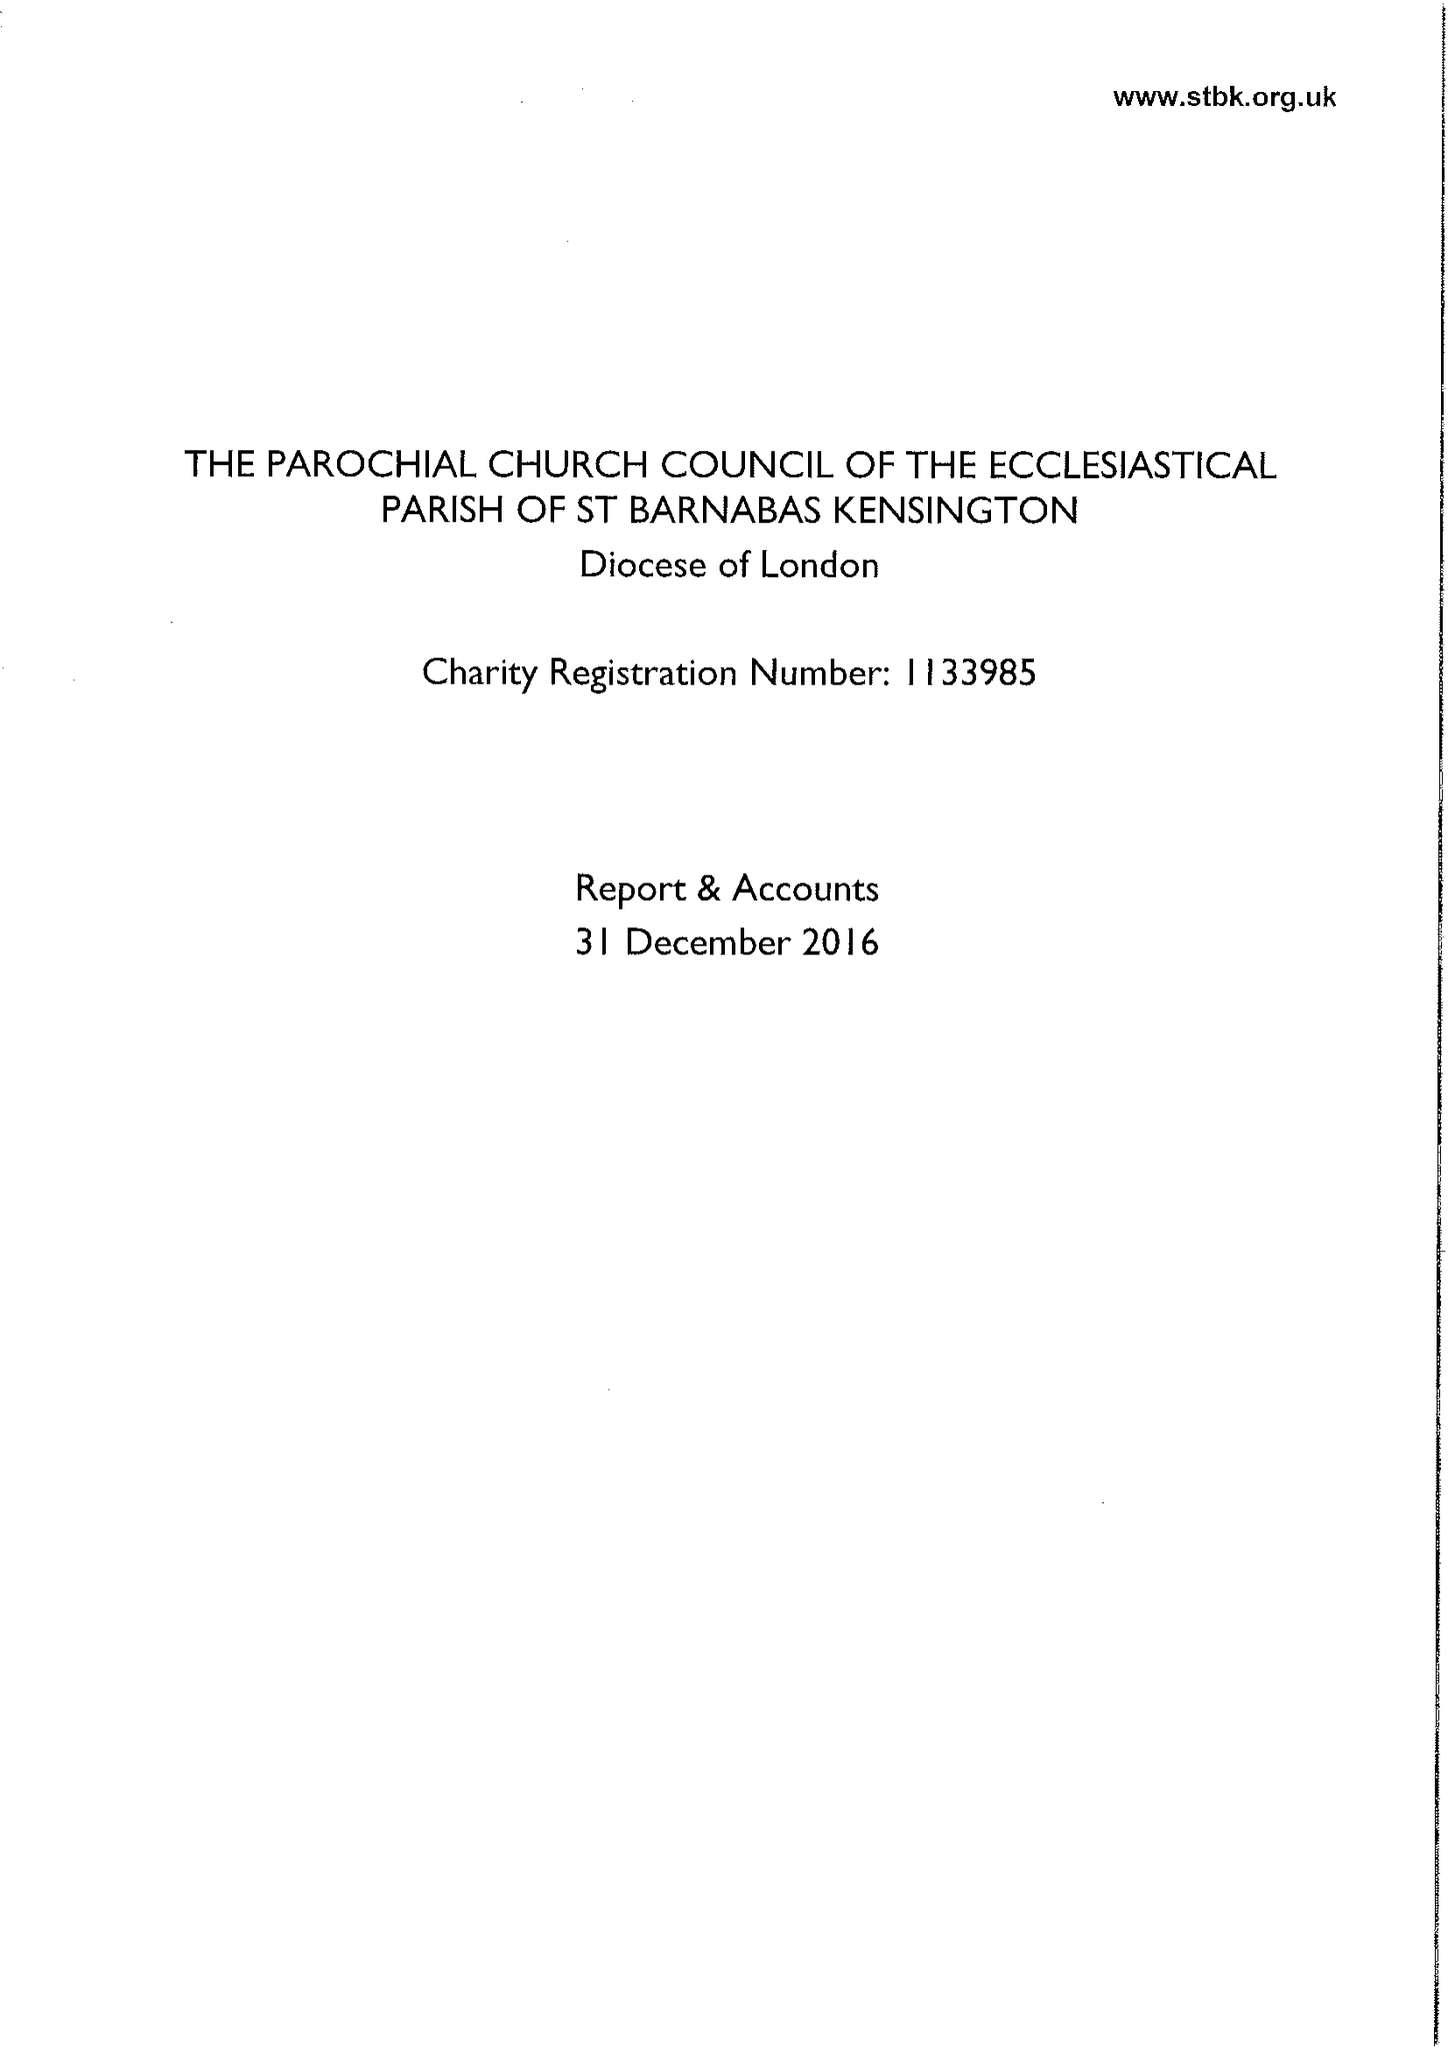What is the value for the address__street_line?
Answer the question using a single word or phrase. 23 ADDISON ROAD 